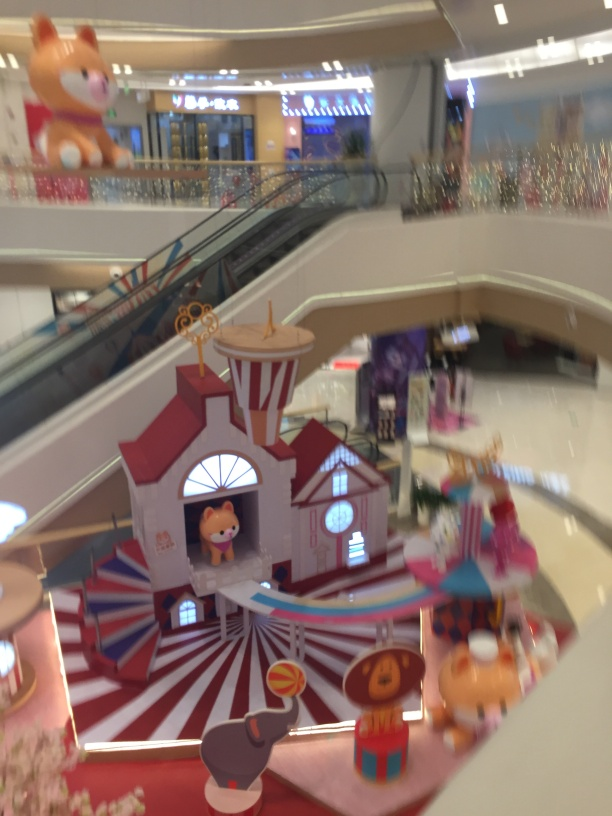What is the quality of this image? The image quality appears to be average due to the motion blur and lack of sharpness which detracts from the overall clarity and details. The setting suggests an indoor amusement or display area, possibly within a shopping mall, but it is difficult to fully appreciate the intricate designs and bright colors due to the suboptimal focus. 